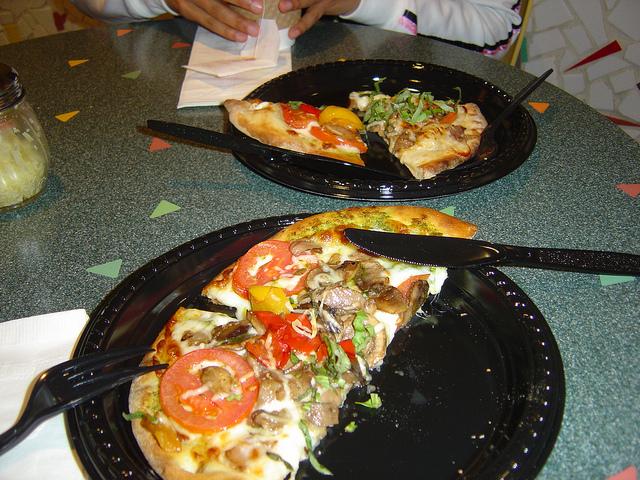How many plates are there?
Concise answer only. 2. Is the table clean?
Write a very short answer. Yes. What utensils are shown?
Quick response, please. Knife and fork. Is the plate black?
Give a very brief answer. Yes. 